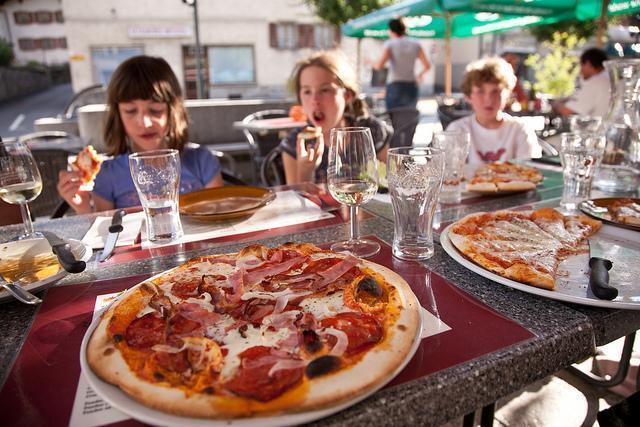How many pizzas are there?
Give a very brief answer. 2. How many cups are there?
Give a very brief answer. 3. How many people are in the photo?
Give a very brief answer. 5. How many wine glasses are there?
Give a very brief answer. 2. How many people are wearing orange jackets?
Give a very brief answer. 0. 